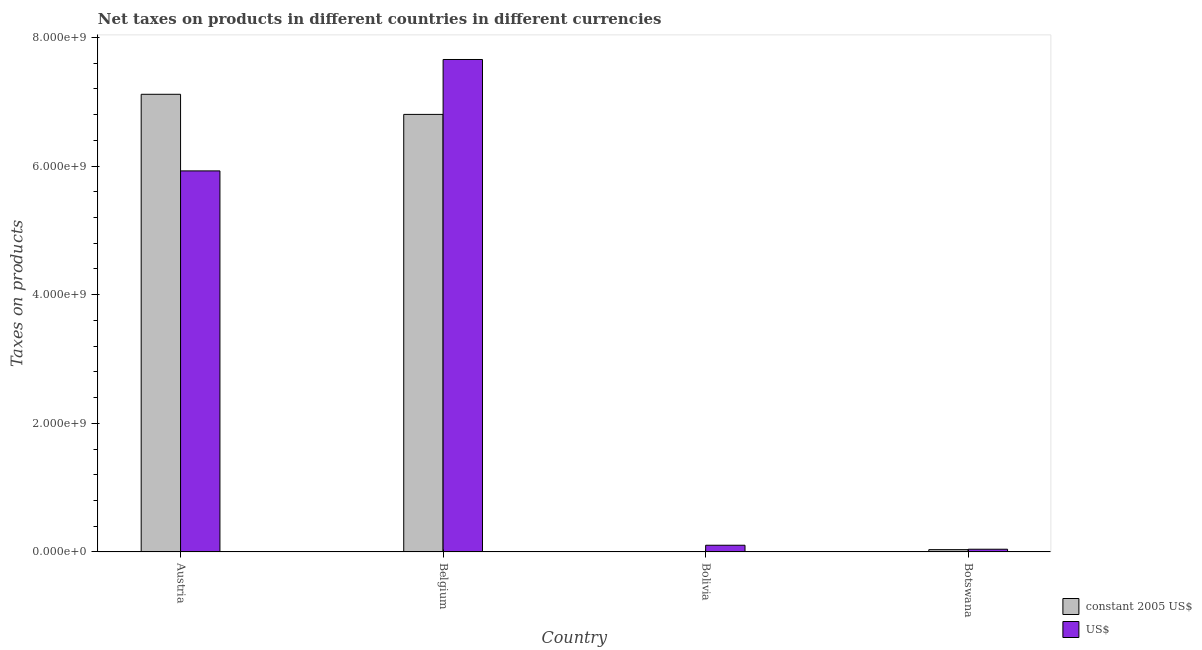Are the number of bars per tick equal to the number of legend labels?
Provide a short and direct response. Yes. In how many cases, is the number of bars for a given country not equal to the number of legend labels?
Keep it short and to the point. 0. What is the net taxes in constant 2005 us$ in Austria?
Your response must be concise. 7.12e+09. Across all countries, what is the maximum net taxes in constant 2005 us$?
Ensure brevity in your answer.  7.12e+09. Across all countries, what is the minimum net taxes in us$?
Make the answer very short. 4.16e+07. What is the total net taxes in constant 2005 us$ in the graph?
Your response must be concise. 1.40e+1. What is the difference between the net taxes in constant 2005 us$ in Belgium and that in Botswana?
Ensure brevity in your answer.  6.77e+09. What is the difference between the net taxes in constant 2005 us$ in Bolivia and the net taxes in us$ in Botswana?
Make the answer very short. -4.16e+07. What is the average net taxes in constant 2005 us$ per country?
Make the answer very short. 3.49e+09. What is the difference between the net taxes in constant 2005 us$ and net taxes in us$ in Belgium?
Give a very brief answer. -8.54e+08. In how many countries, is the net taxes in constant 2005 us$ greater than 6000000000 units?
Offer a terse response. 2. What is the ratio of the net taxes in us$ in Austria to that in Belgium?
Your answer should be very brief. 0.77. Is the net taxes in constant 2005 us$ in Bolivia less than that in Botswana?
Your answer should be very brief. Yes. What is the difference between the highest and the second highest net taxes in us$?
Provide a succinct answer. 1.73e+09. What is the difference between the highest and the lowest net taxes in us$?
Offer a terse response. 7.61e+09. What does the 1st bar from the left in Belgium represents?
Offer a very short reply. Constant 2005 us$. What does the 2nd bar from the right in Belgium represents?
Make the answer very short. Constant 2005 us$. How many countries are there in the graph?
Your answer should be compact. 4. Are the values on the major ticks of Y-axis written in scientific E-notation?
Your response must be concise. Yes. How many legend labels are there?
Your response must be concise. 2. How are the legend labels stacked?
Your answer should be very brief. Vertical. What is the title of the graph?
Give a very brief answer. Net taxes on products in different countries in different currencies. Does "Banks" appear as one of the legend labels in the graph?
Provide a short and direct response. No. What is the label or title of the Y-axis?
Make the answer very short. Taxes on products. What is the Taxes on products of constant 2005 US$ in Austria?
Ensure brevity in your answer.  7.12e+09. What is the Taxes on products of US$ in Austria?
Ensure brevity in your answer.  5.92e+09. What is the Taxes on products of constant 2005 US$ in Belgium?
Give a very brief answer. 6.80e+09. What is the Taxes on products of US$ in Belgium?
Your answer should be very brief. 7.66e+09. What is the Taxes on products of constant 2005 US$ in Bolivia?
Provide a succinct answer. 2073. What is the Taxes on products of US$ in Bolivia?
Ensure brevity in your answer.  1.04e+08. What is the Taxes on products of constant 2005 US$ in Botswana?
Offer a terse response. 3.50e+07. What is the Taxes on products of US$ in Botswana?
Your answer should be compact. 4.16e+07. Across all countries, what is the maximum Taxes on products of constant 2005 US$?
Your answer should be compact. 7.12e+09. Across all countries, what is the maximum Taxes on products in US$?
Make the answer very short. 7.66e+09. Across all countries, what is the minimum Taxes on products in constant 2005 US$?
Make the answer very short. 2073. Across all countries, what is the minimum Taxes on products in US$?
Your response must be concise. 4.16e+07. What is the total Taxes on products of constant 2005 US$ in the graph?
Your answer should be compact. 1.40e+1. What is the total Taxes on products of US$ in the graph?
Provide a succinct answer. 1.37e+1. What is the difference between the Taxes on products in constant 2005 US$ in Austria and that in Belgium?
Your response must be concise. 3.13e+08. What is the difference between the Taxes on products of US$ in Austria and that in Belgium?
Your answer should be compact. -1.73e+09. What is the difference between the Taxes on products of constant 2005 US$ in Austria and that in Bolivia?
Offer a terse response. 7.12e+09. What is the difference between the Taxes on products of US$ in Austria and that in Bolivia?
Your answer should be very brief. 5.82e+09. What is the difference between the Taxes on products in constant 2005 US$ in Austria and that in Botswana?
Offer a very short reply. 7.08e+09. What is the difference between the Taxes on products in US$ in Austria and that in Botswana?
Provide a succinct answer. 5.88e+09. What is the difference between the Taxes on products of constant 2005 US$ in Belgium and that in Bolivia?
Provide a short and direct response. 6.80e+09. What is the difference between the Taxes on products in US$ in Belgium and that in Bolivia?
Ensure brevity in your answer.  7.55e+09. What is the difference between the Taxes on products of constant 2005 US$ in Belgium and that in Botswana?
Make the answer very short. 6.77e+09. What is the difference between the Taxes on products in US$ in Belgium and that in Botswana?
Offer a very short reply. 7.61e+09. What is the difference between the Taxes on products of constant 2005 US$ in Bolivia and that in Botswana?
Make the answer very short. -3.50e+07. What is the difference between the Taxes on products of US$ in Bolivia and that in Botswana?
Provide a succinct answer. 6.20e+07. What is the difference between the Taxes on products of constant 2005 US$ in Austria and the Taxes on products of US$ in Belgium?
Offer a terse response. -5.41e+08. What is the difference between the Taxes on products in constant 2005 US$ in Austria and the Taxes on products in US$ in Bolivia?
Your answer should be very brief. 7.01e+09. What is the difference between the Taxes on products of constant 2005 US$ in Austria and the Taxes on products of US$ in Botswana?
Ensure brevity in your answer.  7.07e+09. What is the difference between the Taxes on products in constant 2005 US$ in Belgium and the Taxes on products in US$ in Bolivia?
Provide a succinct answer. 6.70e+09. What is the difference between the Taxes on products in constant 2005 US$ in Belgium and the Taxes on products in US$ in Botswana?
Ensure brevity in your answer.  6.76e+09. What is the difference between the Taxes on products in constant 2005 US$ in Bolivia and the Taxes on products in US$ in Botswana?
Offer a very short reply. -4.16e+07. What is the average Taxes on products in constant 2005 US$ per country?
Your answer should be very brief. 3.49e+09. What is the average Taxes on products of US$ per country?
Give a very brief answer. 3.43e+09. What is the difference between the Taxes on products in constant 2005 US$ and Taxes on products in US$ in Austria?
Keep it short and to the point. 1.19e+09. What is the difference between the Taxes on products of constant 2005 US$ and Taxes on products of US$ in Belgium?
Give a very brief answer. -8.54e+08. What is the difference between the Taxes on products of constant 2005 US$ and Taxes on products of US$ in Bolivia?
Your answer should be compact. -1.04e+08. What is the difference between the Taxes on products of constant 2005 US$ and Taxes on products of US$ in Botswana?
Ensure brevity in your answer.  -6.58e+06. What is the ratio of the Taxes on products in constant 2005 US$ in Austria to that in Belgium?
Provide a short and direct response. 1.05. What is the ratio of the Taxes on products in US$ in Austria to that in Belgium?
Offer a terse response. 0.77. What is the ratio of the Taxes on products in constant 2005 US$ in Austria to that in Bolivia?
Offer a terse response. 3.43e+06. What is the ratio of the Taxes on products of US$ in Austria to that in Bolivia?
Give a very brief answer. 57.18. What is the ratio of the Taxes on products in constant 2005 US$ in Austria to that in Botswana?
Ensure brevity in your answer.  203. What is the ratio of the Taxes on products of US$ in Austria to that in Botswana?
Give a very brief answer. 142.3. What is the ratio of the Taxes on products of constant 2005 US$ in Belgium to that in Bolivia?
Make the answer very short. 3.28e+06. What is the ratio of the Taxes on products of US$ in Belgium to that in Bolivia?
Your answer should be compact. 73.9. What is the ratio of the Taxes on products in constant 2005 US$ in Belgium to that in Botswana?
Keep it short and to the point. 194.08. What is the ratio of the Taxes on products in US$ in Belgium to that in Botswana?
Provide a short and direct response. 183.91. What is the ratio of the Taxes on products in constant 2005 US$ in Bolivia to that in Botswana?
Provide a succinct answer. 0. What is the ratio of the Taxes on products of US$ in Bolivia to that in Botswana?
Make the answer very short. 2.49. What is the difference between the highest and the second highest Taxes on products of constant 2005 US$?
Your answer should be very brief. 3.13e+08. What is the difference between the highest and the second highest Taxes on products in US$?
Give a very brief answer. 1.73e+09. What is the difference between the highest and the lowest Taxes on products of constant 2005 US$?
Offer a very short reply. 7.12e+09. What is the difference between the highest and the lowest Taxes on products in US$?
Provide a succinct answer. 7.61e+09. 